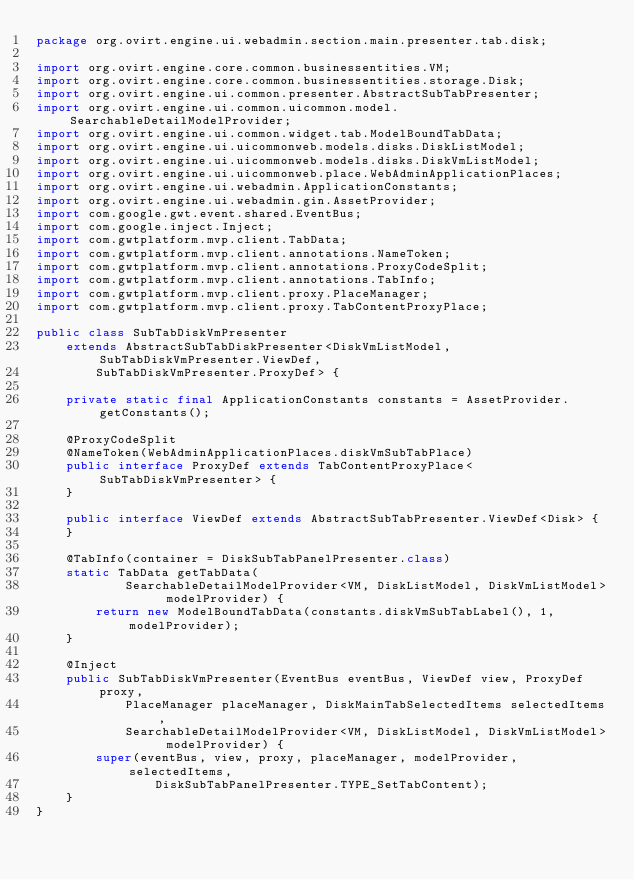Convert code to text. <code><loc_0><loc_0><loc_500><loc_500><_Java_>package org.ovirt.engine.ui.webadmin.section.main.presenter.tab.disk;

import org.ovirt.engine.core.common.businessentities.VM;
import org.ovirt.engine.core.common.businessentities.storage.Disk;
import org.ovirt.engine.ui.common.presenter.AbstractSubTabPresenter;
import org.ovirt.engine.ui.common.uicommon.model.SearchableDetailModelProvider;
import org.ovirt.engine.ui.common.widget.tab.ModelBoundTabData;
import org.ovirt.engine.ui.uicommonweb.models.disks.DiskListModel;
import org.ovirt.engine.ui.uicommonweb.models.disks.DiskVmListModel;
import org.ovirt.engine.ui.uicommonweb.place.WebAdminApplicationPlaces;
import org.ovirt.engine.ui.webadmin.ApplicationConstants;
import org.ovirt.engine.ui.webadmin.gin.AssetProvider;
import com.google.gwt.event.shared.EventBus;
import com.google.inject.Inject;
import com.gwtplatform.mvp.client.TabData;
import com.gwtplatform.mvp.client.annotations.NameToken;
import com.gwtplatform.mvp.client.annotations.ProxyCodeSplit;
import com.gwtplatform.mvp.client.annotations.TabInfo;
import com.gwtplatform.mvp.client.proxy.PlaceManager;
import com.gwtplatform.mvp.client.proxy.TabContentProxyPlace;

public class SubTabDiskVmPresenter
    extends AbstractSubTabDiskPresenter<DiskVmListModel, SubTabDiskVmPresenter.ViewDef,
        SubTabDiskVmPresenter.ProxyDef> {

    private static final ApplicationConstants constants = AssetProvider.getConstants();

    @ProxyCodeSplit
    @NameToken(WebAdminApplicationPlaces.diskVmSubTabPlace)
    public interface ProxyDef extends TabContentProxyPlace<SubTabDiskVmPresenter> {
    }

    public interface ViewDef extends AbstractSubTabPresenter.ViewDef<Disk> {
    }

    @TabInfo(container = DiskSubTabPanelPresenter.class)
    static TabData getTabData(
            SearchableDetailModelProvider<VM, DiskListModel, DiskVmListModel> modelProvider) {
        return new ModelBoundTabData(constants.diskVmSubTabLabel(), 1, modelProvider);
    }

    @Inject
    public SubTabDiskVmPresenter(EventBus eventBus, ViewDef view, ProxyDef proxy,
            PlaceManager placeManager, DiskMainTabSelectedItems selectedItems,
            SearchableDetailModelProvider<VM, DiskListModel, DiskVmListModel> modelProvider) {
        super(eventBus, view, proxy, placeManager, modelProvider, selectedItems,
                DiskSubTabPanelPresenter.TYPE_SetTabContent);
    }
}
</code> 